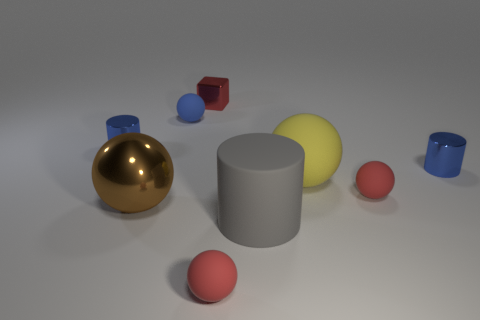There is a yellow thing; is it the same size as the cylinder to the left of the big cylinder?
Make the answer very short. No. There is a red rubber thing to the left of the gray matte thing; is it the same size as the gray thing?
Your response must be concise. No. What shape is the metallic object behind the tiny blue ball?
Provide a short and direct response. Cube. There is a large yellow thing that is made of the same material as the tiny blue ball; what is its shape?
Ensure brevity in your answer.  Sphere. Is there any other thing that has the same shape as the red metal thing?
Ensure brevity in your answer.  No. There is a cube; what number of shiny cylinders are to the left of it?
Your answer should be very brief. 1. Is the number of big things that are to the left of the block the same as the number of gray matte cylinders?
Provide a short and direct response. Yes. Do the big yellow sphere and the cube have the same material?
Keep it short and to the point. No. There is a red object that is behind the gray cylinder and in front of the tiny red block; what is its size?
Your answer should be very brief. Small. How many yellow matte objects are the same size as the brown object?
Offer a terse response. 1. 